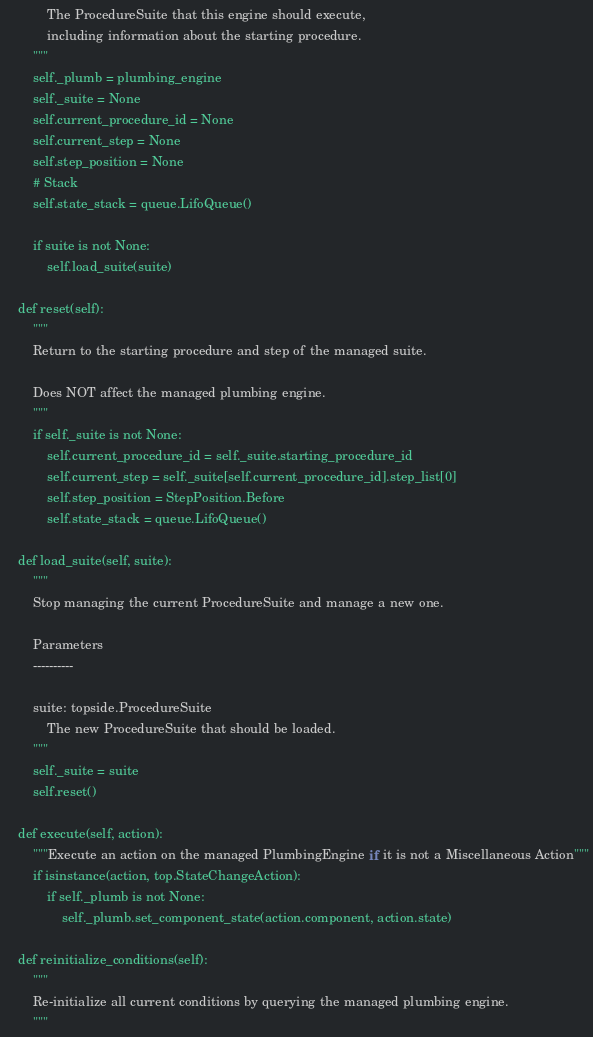Convert code to text. <code><loc_0><loc_0><loc_500><loc_500><_Python_>            The ProcedureSuite that this engine should execute,
            including information about the starting procedure.
        """
        self._plumb = plumbing_engine
        self._suite = None
        self.current_procedure_id = None
        self.current_step = None
        self.step_position = None
        # Stack
        self.state_stack = queue.LifoQueue()

        if suite is not None:
            self.load_suite(suite)

    def reset(self):
        """
        Return to the starting procedure and step of the managed suite.

        Does NOT affect the managed plumbing engine.
        """
        if self._suite is not None:
            self.current_procedure_id = self._suite.starting_procedure_id
            self.current_step = self._suite[self.current_procedure_id].step_list[0]
            self.step_position = StepPosition.Before
            self.state_stack = queue.LifoQueue()

    def load_suite(self, suite):
        """
        Stop managing the current ProcedureSuite and manage a new one.

        Parameters
        ----------

        suite: topside.ProcedureSuite
            The new ProcedureSuite that should be loaded.
        """
        self._suite = suite
        self.reset()

    def execute(self, action):
        """Execute an action on the managed PlumbingEngine if it is not a Miscellaneous Action"""
        if isinstance(action, top.StateChangeAction):
            if self._plumb is not None:
                self._plumb.set_component_state(action.component, action.state)

    def reinitialize_conditions(self):
        """
        Re-initialize all current conditions by querying the managed plumbing engine.
        """</code> 